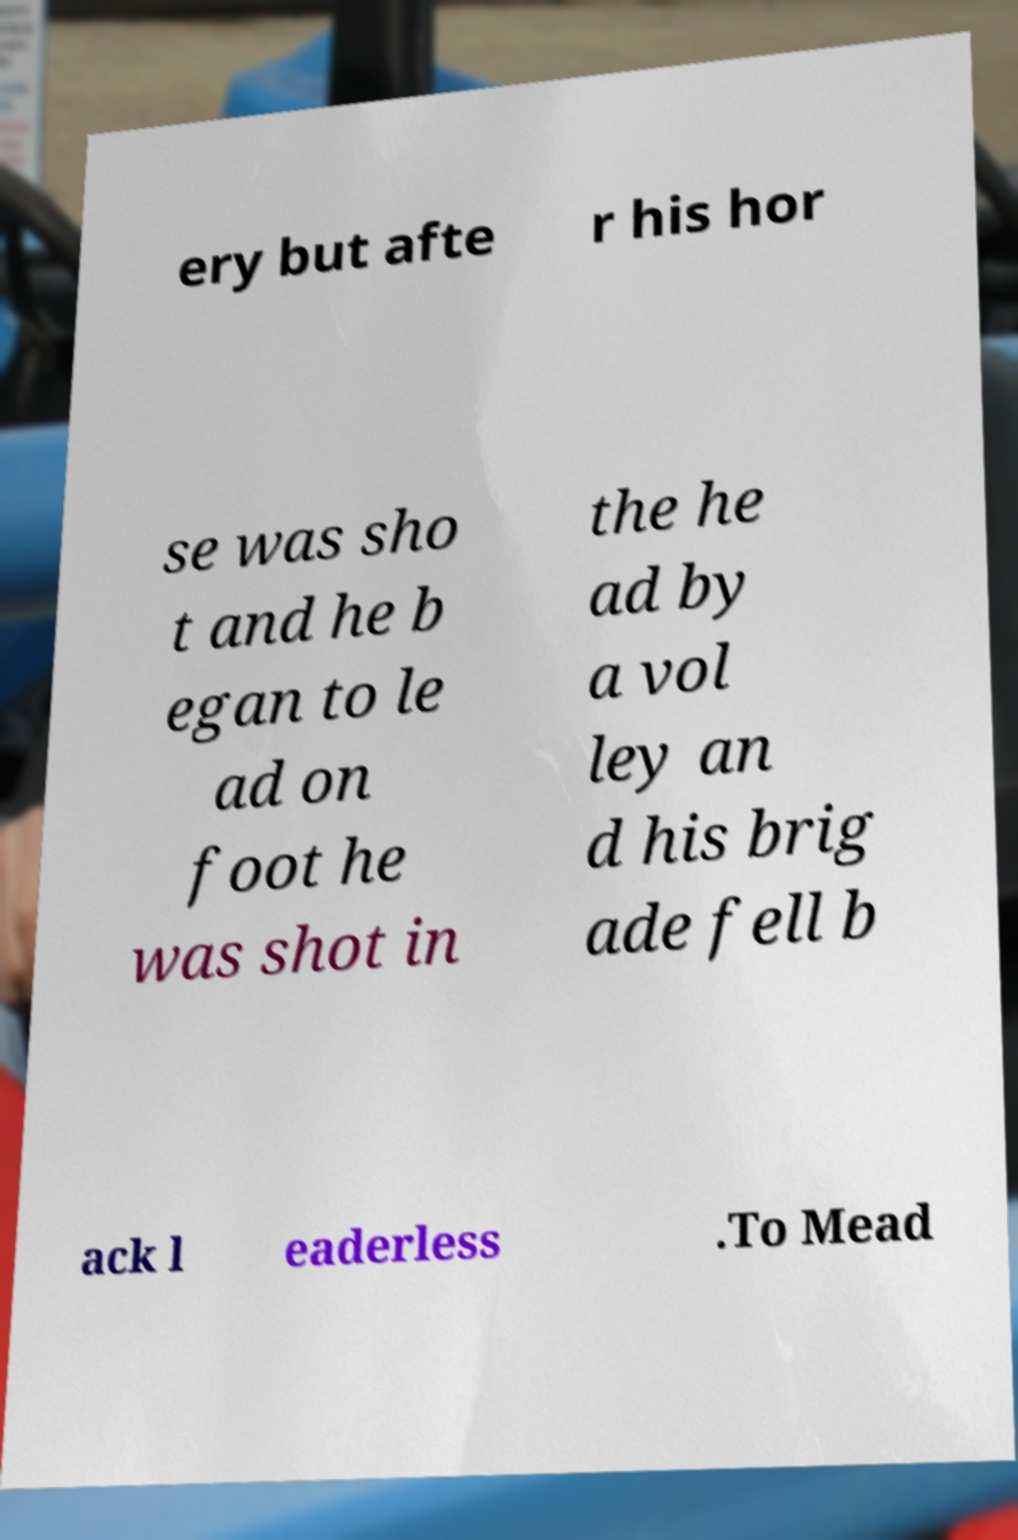Could you extract and type out the text from this image? ery but afte r his hor se was sho t and he b egan to le ad on foot he was shot in the he ad by a vol ley an d his brig ade fell b ack l eaderless .To Mead 